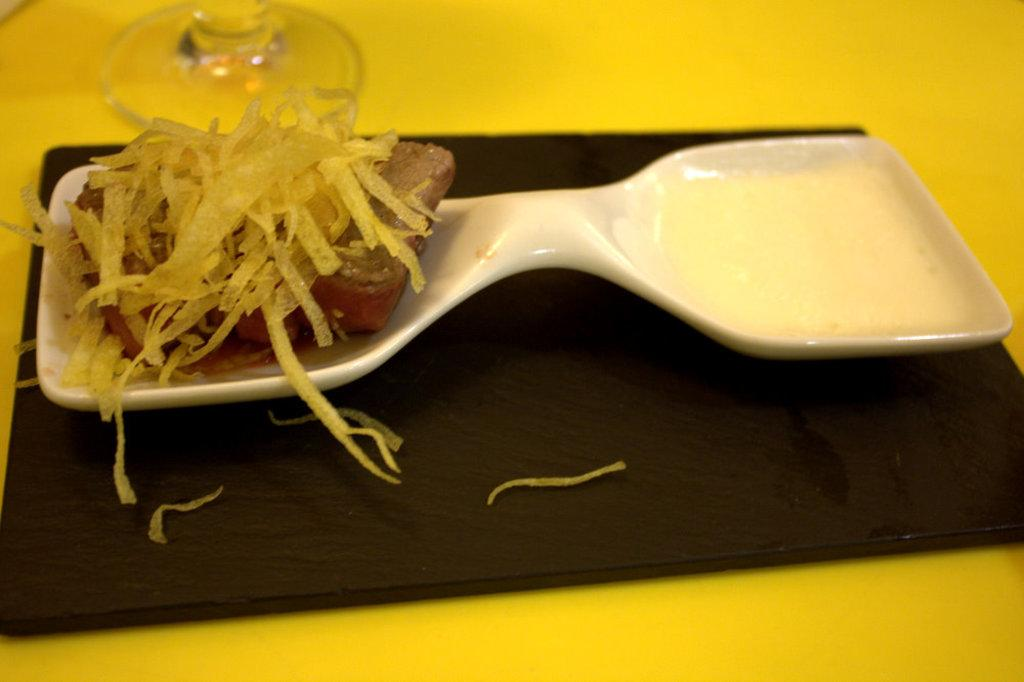What is on the plate that is visible in the image? There is a plate containing food in the image. Where is the plate located in the image? The plate is placed on a surface in the image. What else can be seen in the image besides the plate? There is a glass in the image. How is the glass positioned in the image? The glass is at the top of the image. Is there a quiver of arrows visible in the image? No, there is no quiver of arrows present in the image. 